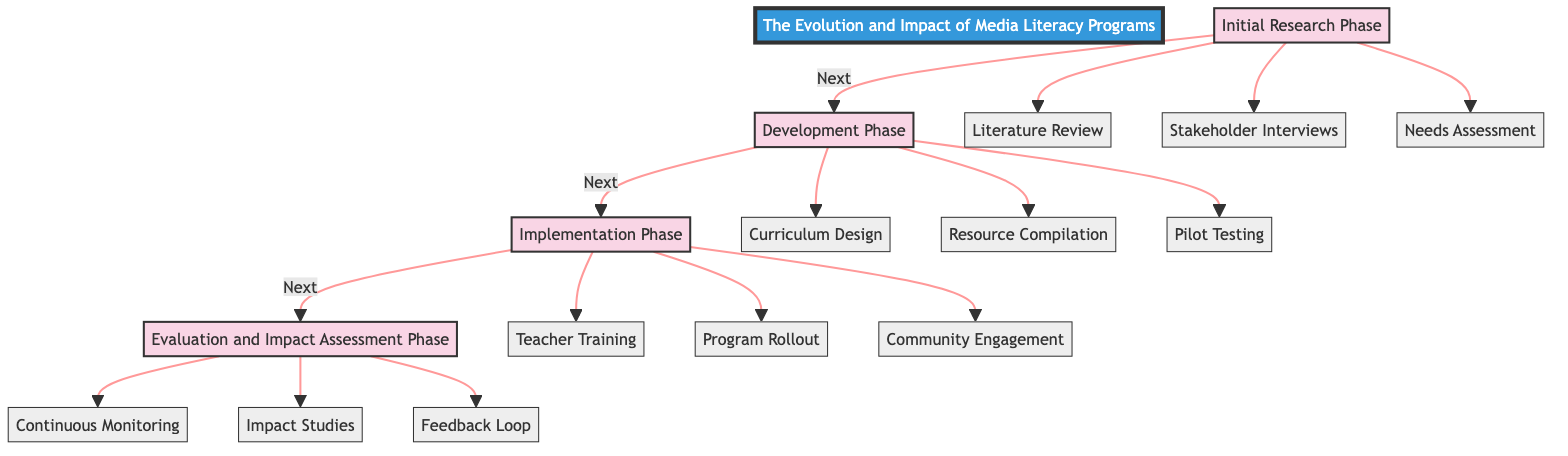What are the four main phases outlined in the diagram? The diagram exhibits four distinct phases: Initial Research Phase, Development Phase, Implementation Phase, and Evaluation and Impact Assessment Phase. These phases are labeled and connected sequentially, indicating the order of the clinical pathway stages.
Answer: Initial Research Phase, Development Phase, Implementation Phase, Evaluation and Impact Assessment Phase How many elements are listed under the Implementation Phase? Under the Implementation Phase, there are three elements: Teacher Training, Program Rollout, and Community Engagement. The diagram shows these elements connected to the Implementation Phase node, indicating they belong to that stage.
Answer: 3 What comes after the Development Phase? In the clinical pathway diagram, the Development Phase is directly followed by the Implementation Phase, as indicated by the arrow connecting these two nodes, showing the progression from one phase to the next.
Answer: Implementation Phase How many elements are in total across all phases? The total number of elements is calculated by adding the number of elements in each phase: 3 (Initial Research Phase) + 3 (Development Phase) + 3 (Implementation Phase) + 3 (Evaluation and Impact Assessment Phase), resulting in a total of 12 elements.
Answer: 12 Which element focuses on understanding existing stereotypes? The Stakeholder Interviews element within the Initial Research Phase focuses on understanding existing stereotypes, as it specifically involves engaging with media experts and community leaders to gather insights on the subject matter.
Answer: Stakeholder Interviews Which phase includes 'Impact Studies'? The Impact Studies element belongs to the Evaluation and Impact Assessment Phase, where it aims to formally evaluate the effectiveness and impact of the media literacy programs on stereotype reduction. The diagram clearly places this element under the corresponding phase.
Answer: Evaluation and Impact Assessment Phase What is the purpose of the Feedback Loop? The Feedback Loop is designed to collect feedback from participants and educators continuously. It serves to improve the curriculum and resources over time, emphasizing the program's adaptive nature as indicated in the Evaluation and Impact Assessment Phase.
Answer: Continuous improvement Which phase addresses the issue of curriculum design? The curriculum design is addressed in the Development Phase, where crucial educational materials are created based on the findings from the Initial Research Phase. The diagram connects this element specifically to the developmental stage.
Answer: Development Phase 